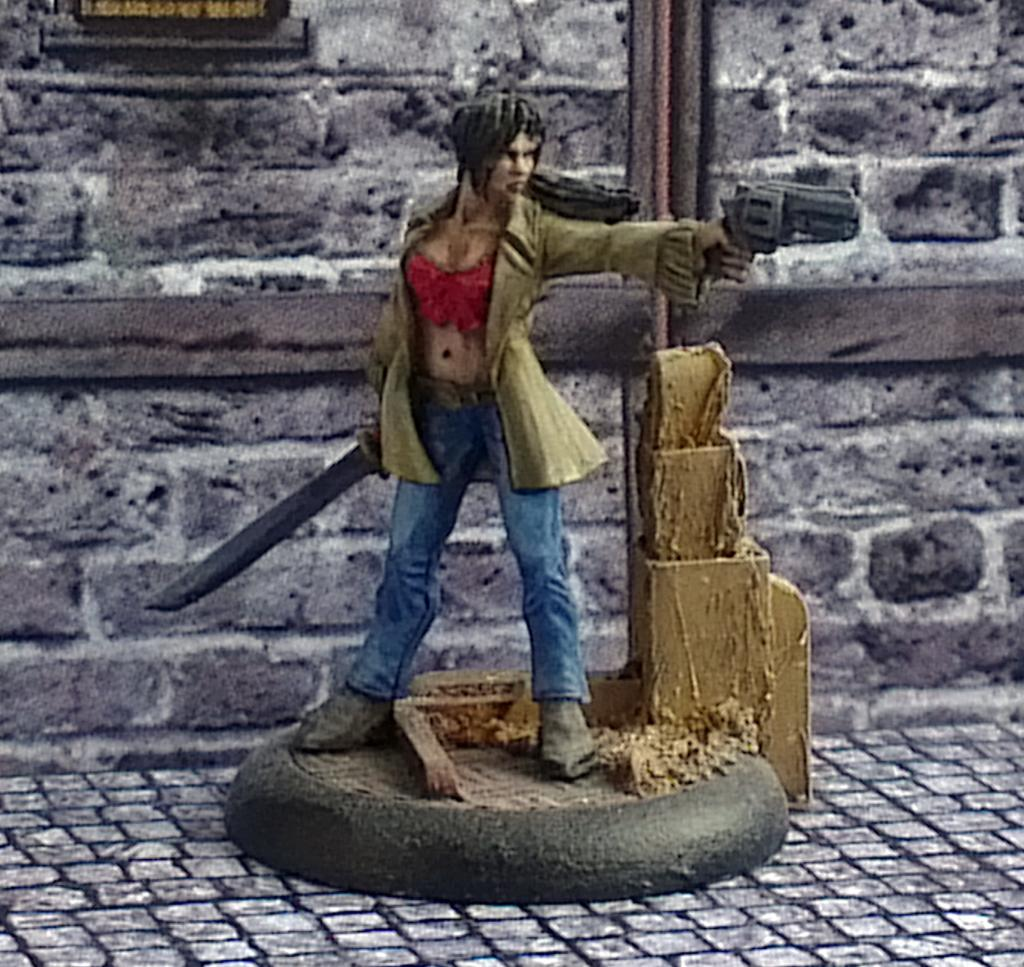What is the main subject of the image? There is a woman in the image. What is the woman doing in the image? The woman is standing on the floor and holding a knife in one hand and a gun in the other hand. What can be seen in the background of the image? There is a wall and a window in the background of the image. What type of quiet dinosaur can be seen wearing a mitten in the image? There are no dinosaurs or mittens present in the image. 